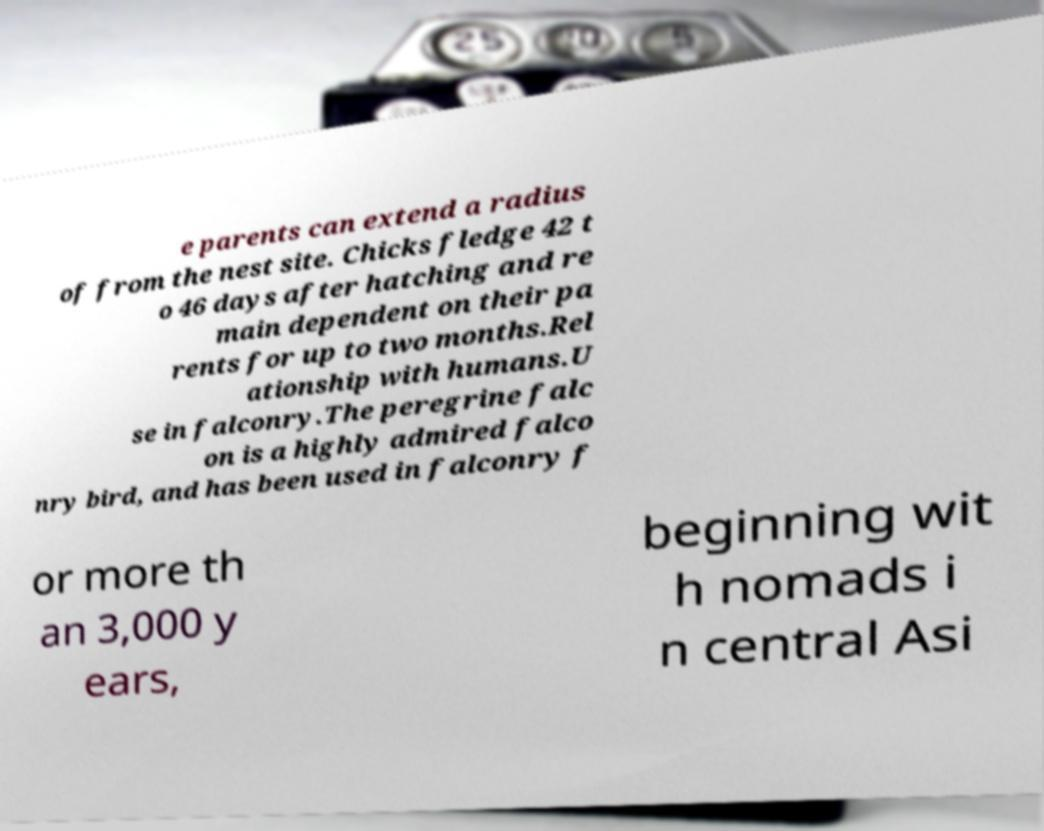Can you read and provide the text displayed in the image?This photo seems to have some interesting text. Can you extract and type it out for me? e parents can extend a radius of from the nest site. Chicks fledge 42 t o 46 days after hatching and re main dependent on their pa rents for up to two months.Rel ationship with humans.U se in falconry.The peregrine falc on is a highly admired falco nry bird, and has been used in falconry f or more th an 3,000 y ears, beginning wit h nomads i n central Asi 